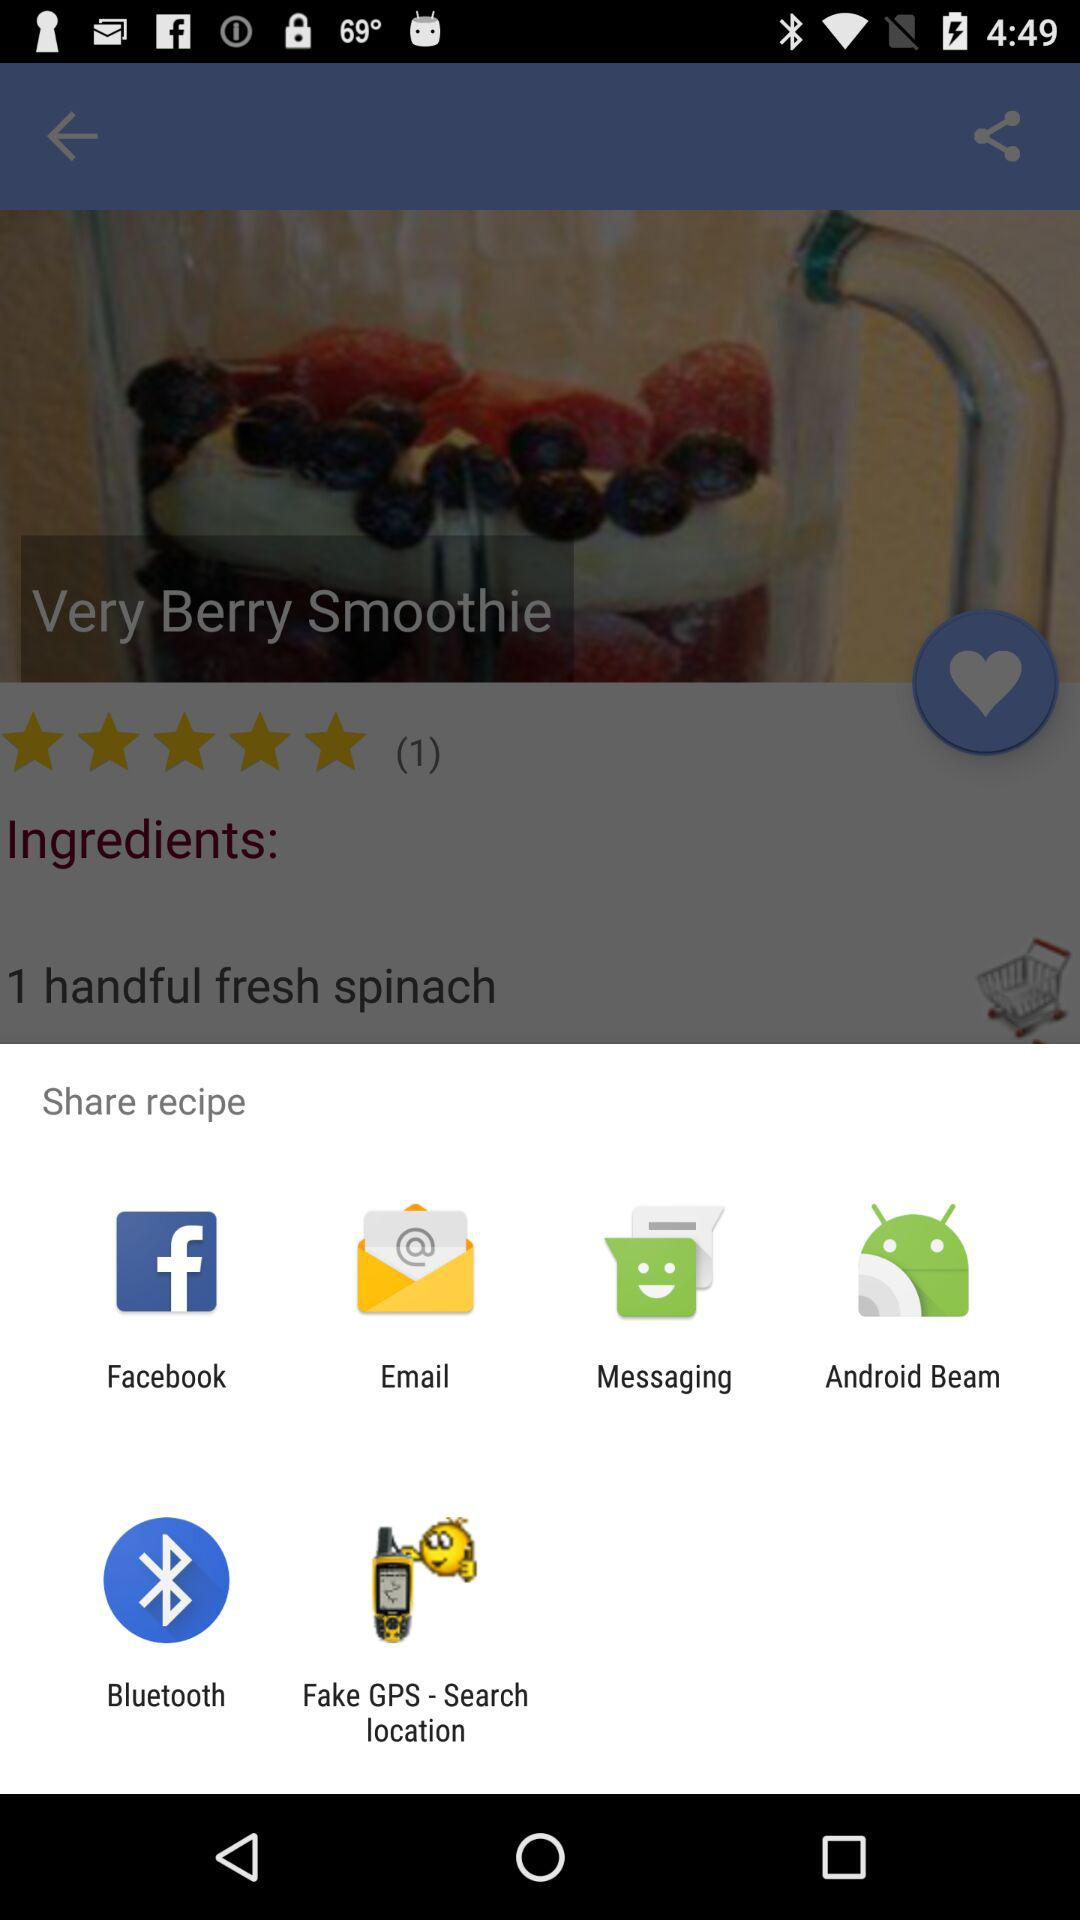What is the given rating? The given rating is 5 stars. 